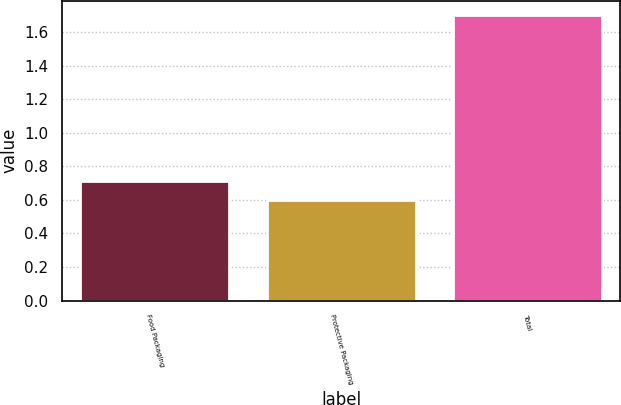<chart> <loc_0><loc_0><loc_500><loc_500><bar_chart><fcel>Food Packaging<fcel>Protective Packaging<fcel>Total<nl><fcel>0.71<fcel>0.6<fcel>1.7<nl></chart> 